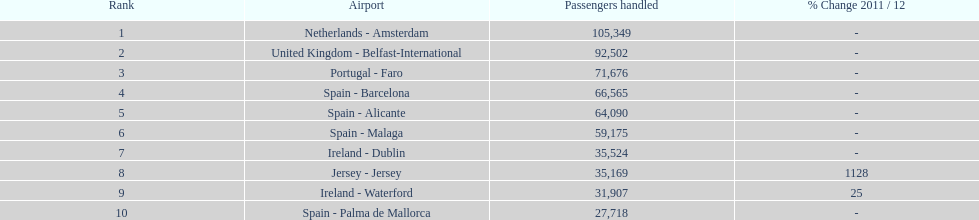Parse the table in full. {'header': ['Rank', 'Airport', 'Passengers handled', '% Change 2011 / 12'], 'rows': [['1', 'Netherlands - Amsterdam', '105,349', '-'], ['2', 'United Kingdom - Belfast-International', '92,502', '-'], ['3', 'Portugal - Faro', '71,676', '-'], ['4', 'Spain - Barcelona', '66,565', '-'], ['5', 'Spain - Alicante', '64,090', '-'], ['6', 'Spain - Malaga', '59,175', '-'], ['7', 'Ireland - Dublin', '35,524', '-'], ['8', 'Jersey - Jersey', '35,169', '1128'], ['9', 'Ireland - Waterford', '31,907', '25'], ['10', 'Spain - Palma de Mallorca', '27,718', '-']]} How many individuals were processed at an airport in spain? 217,548. 